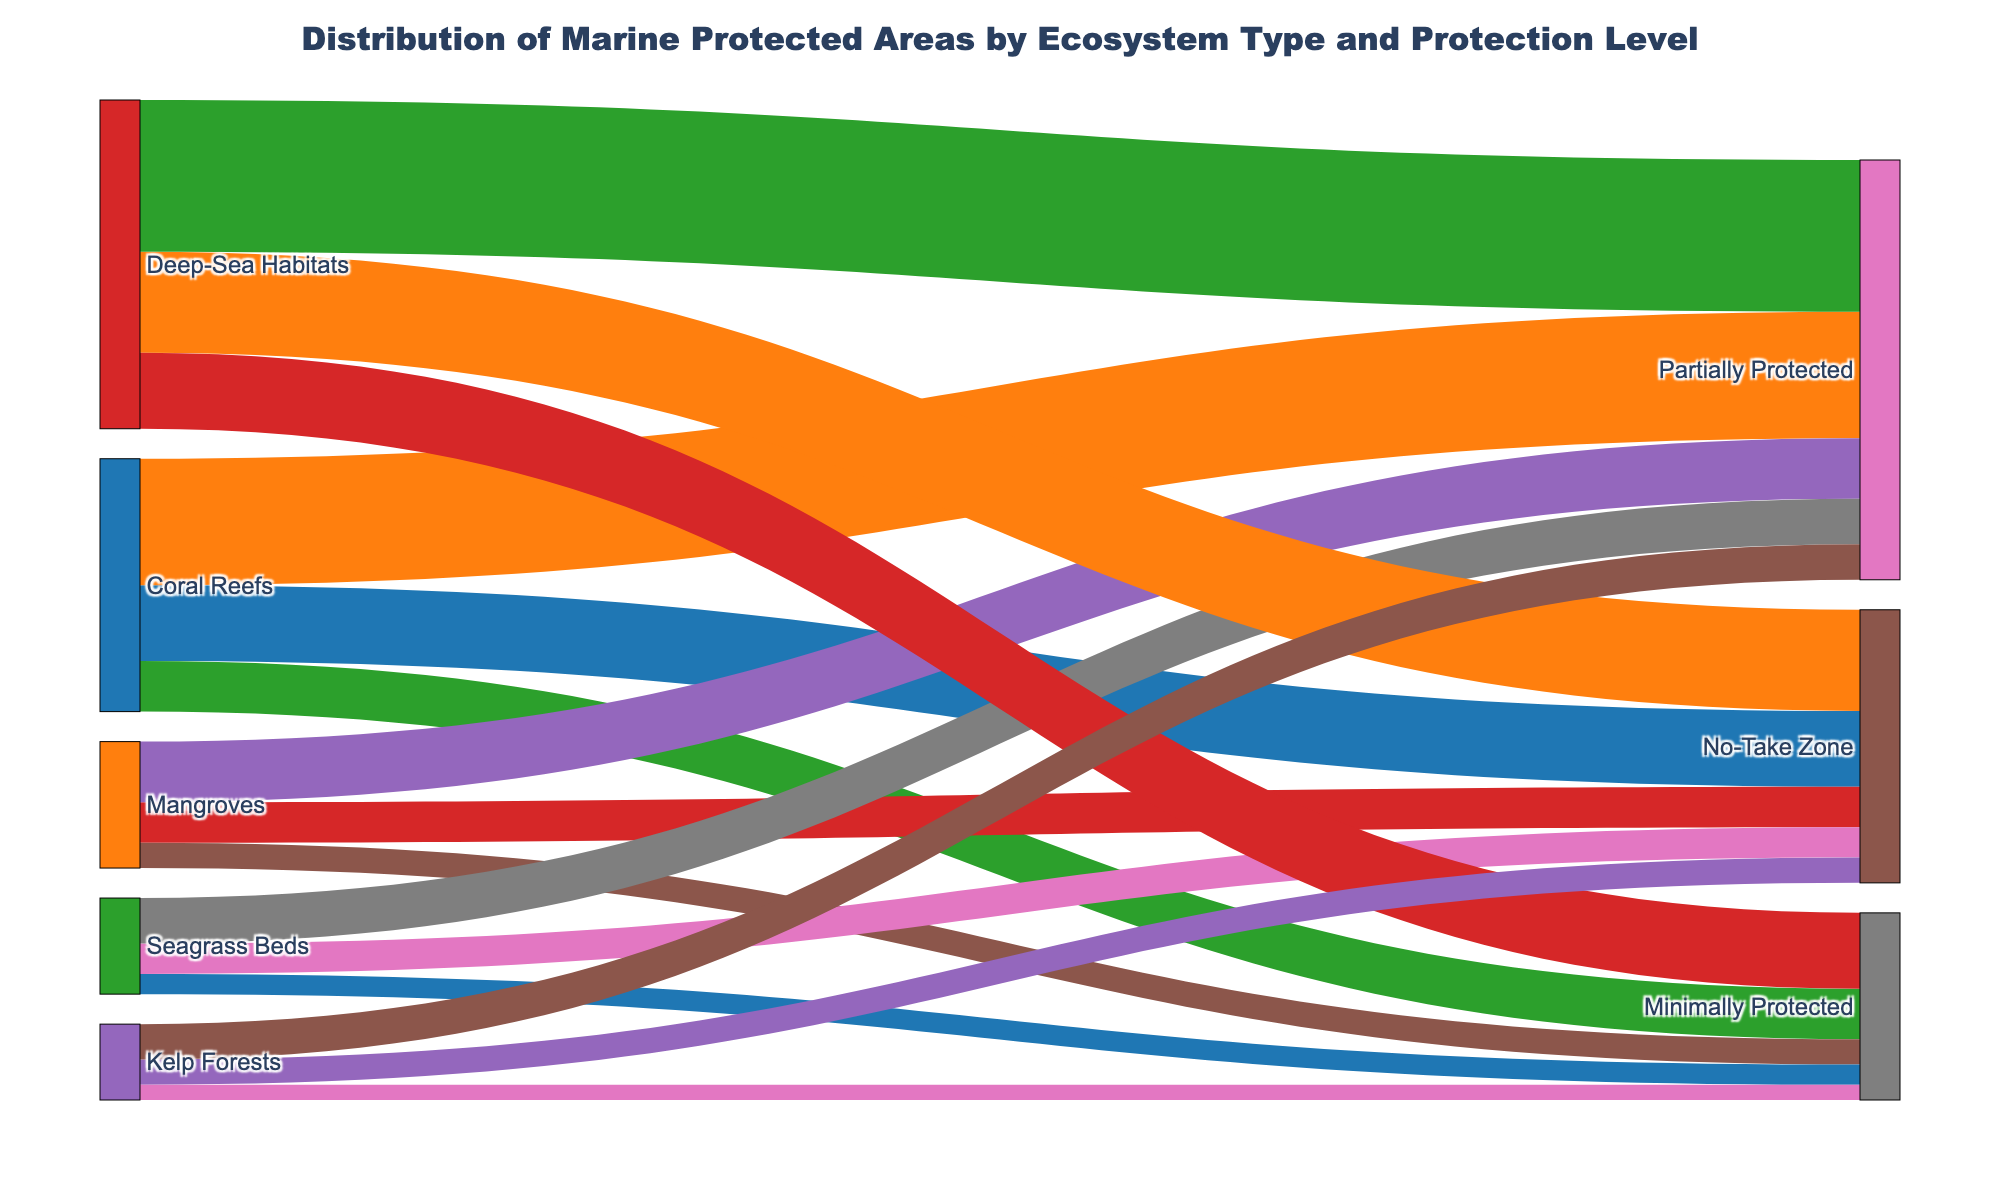What is the total area of marine protected areas for Coral Reefs? Look at the figure and sum the areas for all protection levels under Coral Reefs: 15000 (No-Take Zone) + 25000 (Partially Protected) + 10000 (Minimally Protected)
Answer: 50000 km² Which ecosystem has the smallest area of No-Take Zones? Compare the areas of No-Take Zones for each ecosystem: Coral Reefs (15000 km²), Mangroves (8000 km²), Seagrass Beds (6000 km²), Deep-Sea Habitats (20000 km²), Kelp Forests (5000 km²). Kelp Forests has the smallest No-Take Zone area.
Answer: Kelp Forests What is the total area for all ecosystems with Partially Protected zones? Sum the Partially Protected areas for all ecosystems: Coral Reefs (25000 km²) + Mangroves (12000 km²) + Seagrass Beds (9000 km²) + Deep-Sea Habitats (30000 km²) + Kelp Forests (7000 km²)
Answer: 83000 km² Which ecosystem has the highest total protected area? Add up all protection levels for each ecosystem: Coral Reefs (50000 km²), Mangroves (25000 km²), Seagrass Beds (19000 km²), Deep-Sea Habitats (65000 km²), Kelp Forests (15000 km²). Deep-Sea Habitats has the highest total protected area.
Answer: Deep-Sea Habitats How many ecosystem types are represented in the figure? Identify the unique ecosystem types in the diagram: Coral Reefs, Mangroves, Seagrass Beds, Deep-Sea Habitats, Kelp Forests
Answer: 5 Which protection level has the smallest total area across all ecosystems? Sum the areas for each protection level across all ecosystems: No-Take Zone (54000 km²), Partially Protected (83000 km²), Minimally Protected (37000 km²). Minimally Protected has the smallest total area.
Answer: Minimally Protected How much larger is the area of No-Take Zones in Deep-Sea Habitats compared to Kelp Forests? Subtract the No-Take Zone area of Kelp Forests (5000 km²) from that of Deep-Sea Habitats (20000 km²)
Answer: 15000 km² What is the total area for all marine protected areas shown in the figure? Sum the areas for all protection levels across all ecosystems: 15000 + 25000 + 10000 + 8000 + 12000 + 5000 + 6000 + 9000 + 4000 + 20000 + 30000 + 15000 + 5000 + 7000 + 3000
Answer: 174000 km² What proportion of the Coral Reefs protected areas are No-Take Zones? Divide the No-Take Zone area of Coral Reefs (15000 km²) by the total Coral Reefs protected area (50000 km²) and convert to a percentage
Answer: 30% 